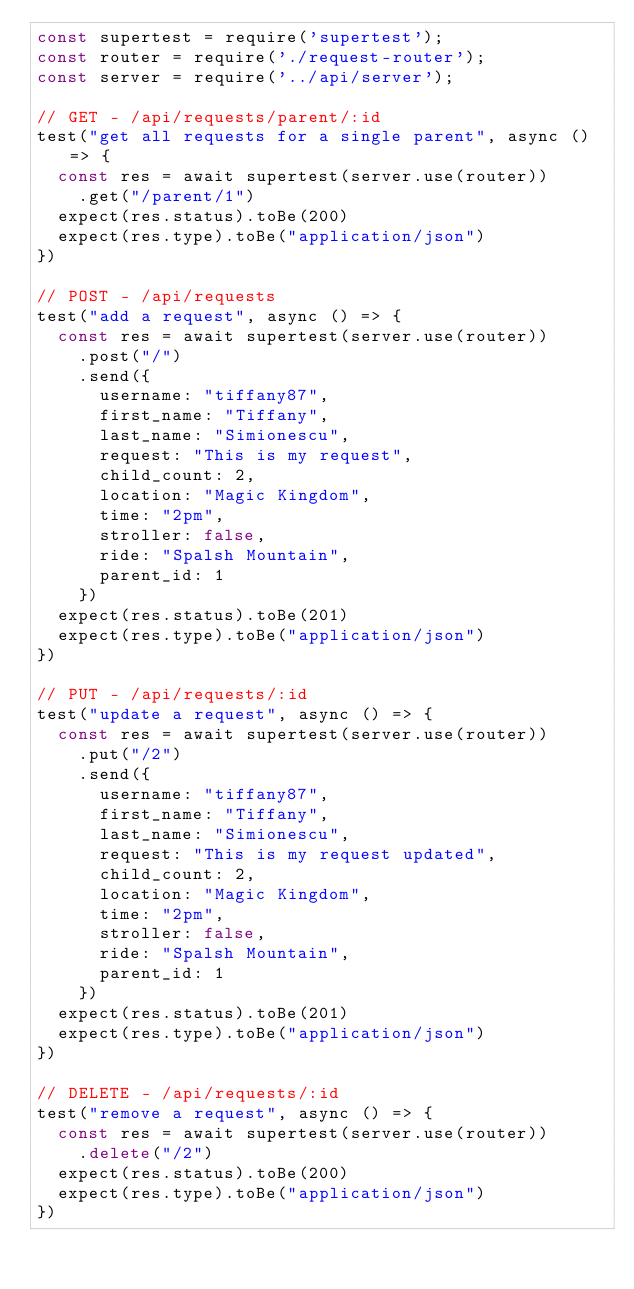Convert code to text. <code><loc_0><loc_0><loc_500><loc_500><_JavaScript_>const supertest = require('supertest');
const router = require('./request-router');
const server = require('../api/server');

// GET - /api/requests/parent/:id
test("get all requests for a single parent", async () => {
  const res = await supertest(server.use(router))
    .get("/parent/1")
  expect(res.status).toBe(200)
  expect(res.type).toBe("application/json")
})

// POST - /api/requests
test("add a request", async () => {
  const res = await supertest(server.use(router))
    .post("/")
    .send({
      username: "tiffany87",
      first_name: "Tiffany",
      last_name: "Simionescu",
      request: "This is my request",
      child_count: 2,
      location: "Magic Kingdom",
      time: "2pm",
      stroller: false,
      ride: "Spalsh Mountain",
      parent_id: 1
    })
  expect(res.status).toBe(201)
  expect(res.type).toBe("application/json")
})

// PUT - /api/requests/:id
test("update a request", async () => {
  const res = await supertest(server.use(router))
    .put("/2")
    .send({
      username: "tiffany87",
      first_name: "Tiffany",
      last_name: "Simionescu",
      request: "This is my request updated",
      child_count: 2,
      location: "Magic Kingdom",
      time: "2pm",
      stroller: false,
      ride: "Spalsh Mountain",
      parent_id: 1
    })
  expect(res.status).toBe(201)
  expect(res.type).toBe("application/json")
})

// DELETE - /api/requests/:id
test("remove a request", async () => {
  const res = await supertest(server.use(router))
    .delete("/2")
  expect(res.status).toBe(200)
  expect(res.type).toBe("application/json")
})</code> 